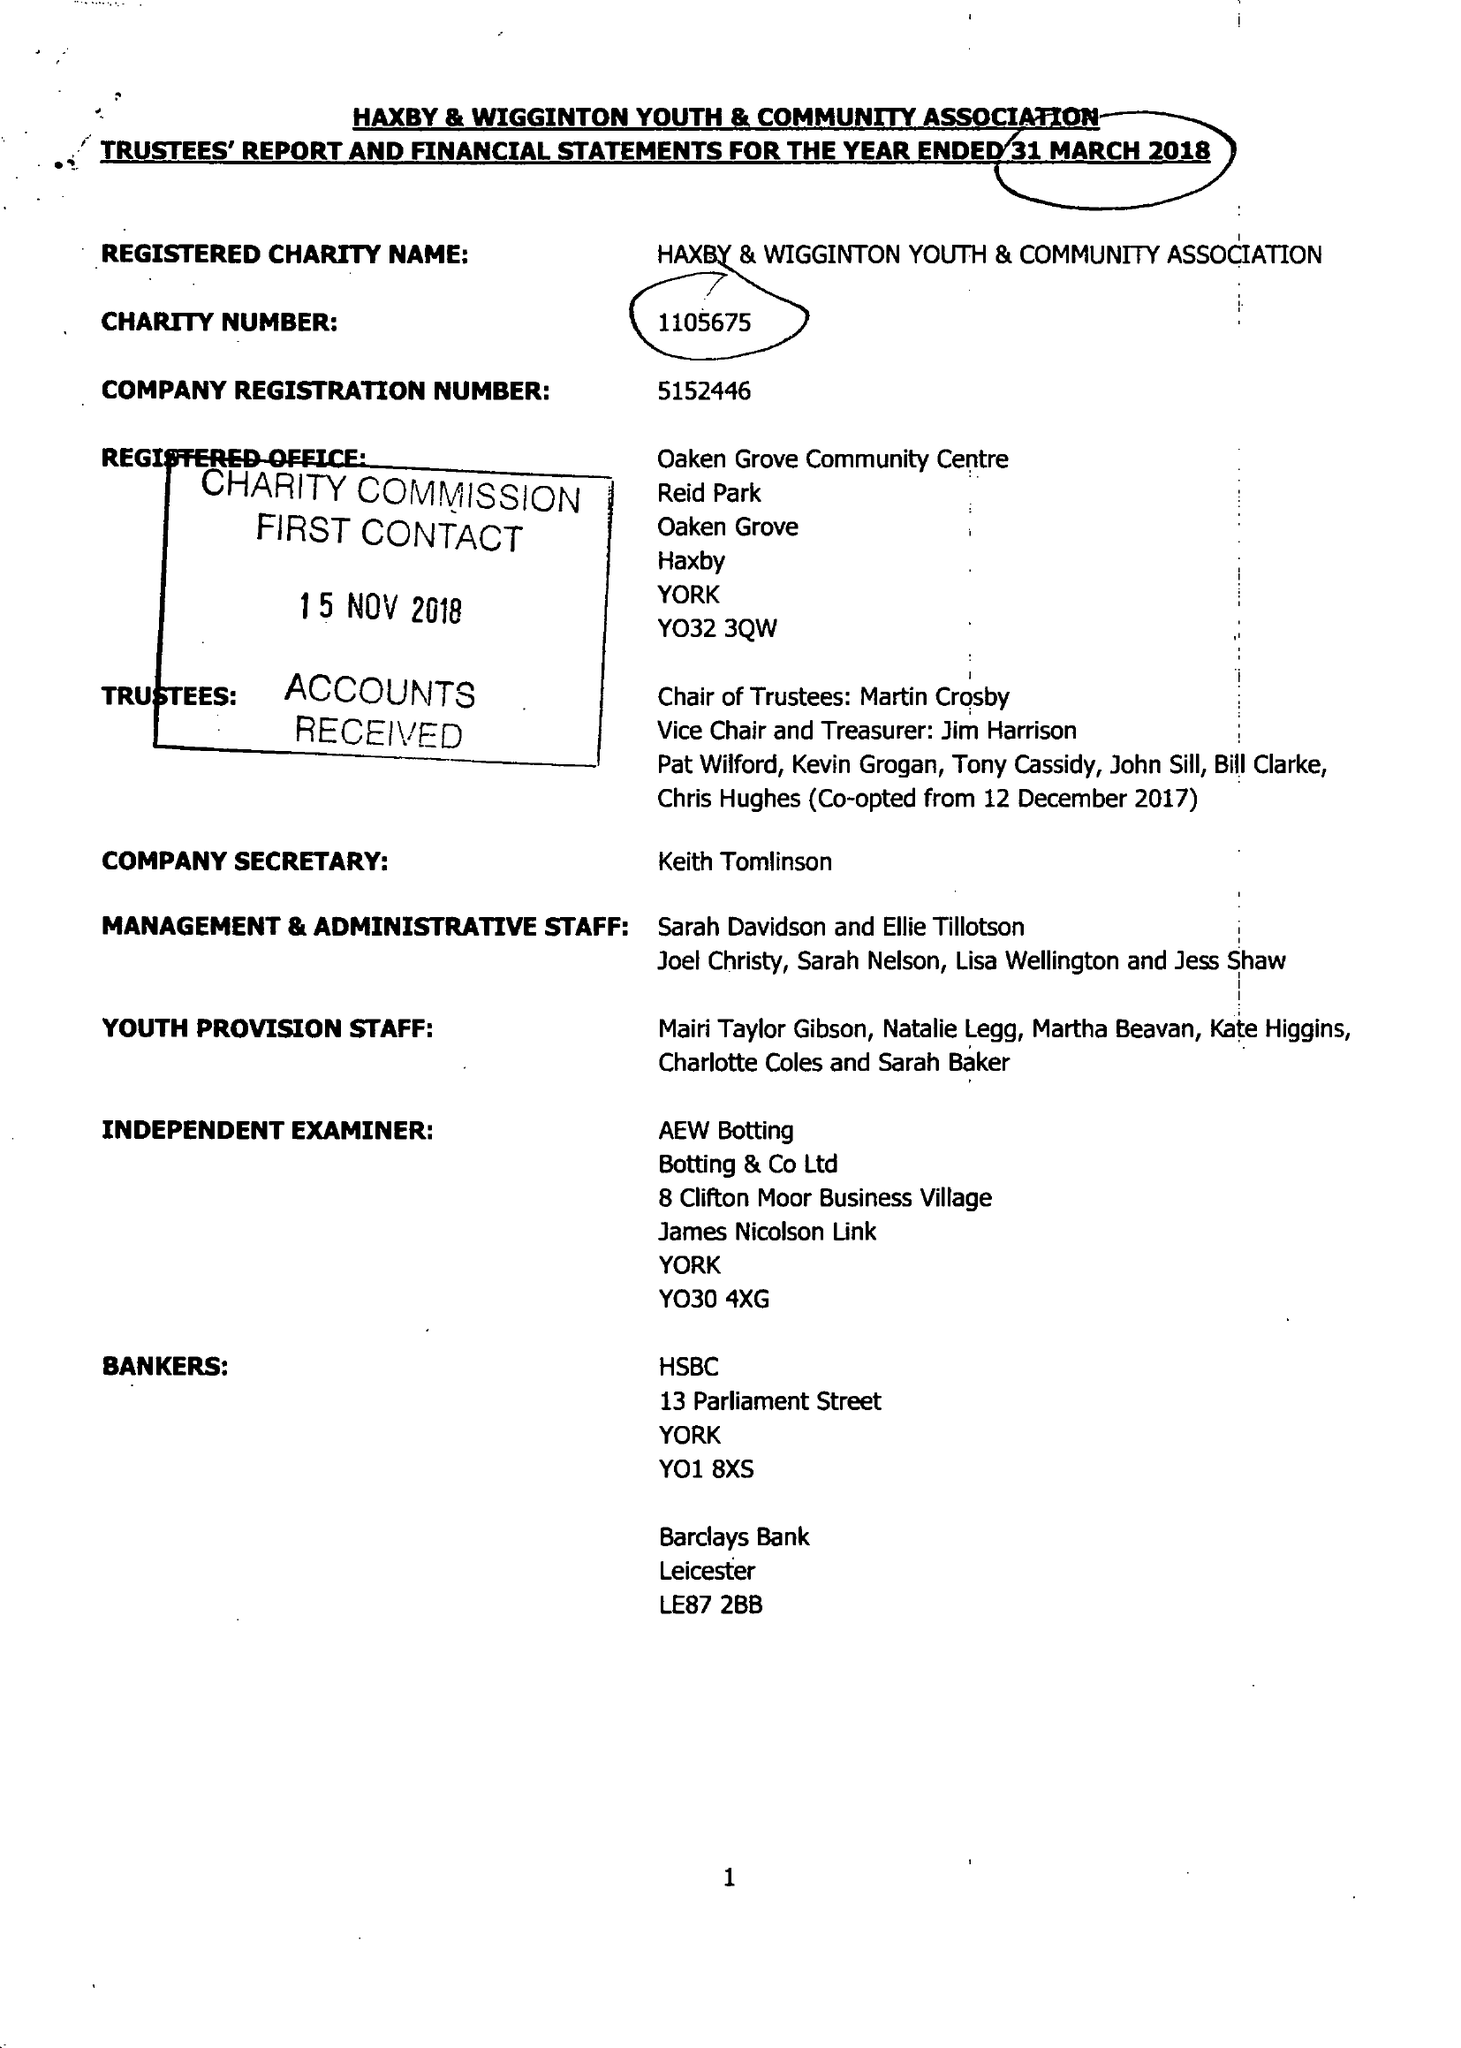What is the value for the charity_number?
Answer the question using a single word or phrase. 1105675 